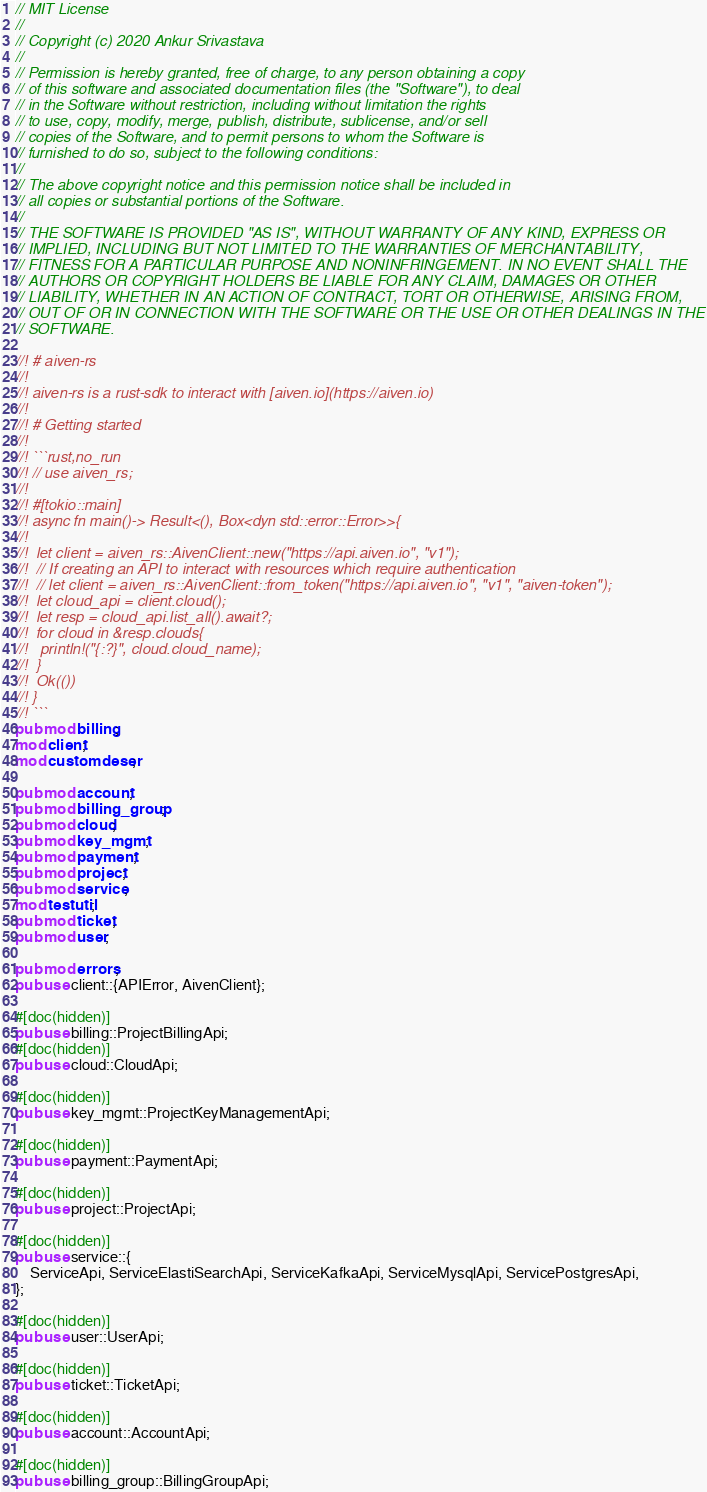<code> <loc_0><loc_0><loc_500><loc_500><_Rust_>// MIT License
//
// Copyright (c) 2020 Ankur Srivastava
//
// Permission is hereby granted, free of charge, to any person obtaining a copy
// of this software and associated documentation files (the "Software"), to deal
// in the Software without restriction, including without limitation the rights
// to use, copy, modify, merge, publish, distribute, sublicense, and/or sell
// copies of the Software, and to permit persons to whom the Software is
// furnished to do so, subject to the following conditions:
//
// The above copyright notice and this permission notice shall be included in
// all copies or substantial portions of the Software.
//
// THE SOFTWARE IS PROVIDED "AS IS", WITHOUT WARRANTY OF ANY KIND, EXPRESS OR
// IMPLIED, INCLUDING BUT NOT LIMITED TO THE WARRANTIES OF MERCHANTABILITY,
// FITNESS FOR A PARTICULAR PURPOSE AND NONINFRINGEMENT. IN NO EVENT SHALL THE
// AUTHORS OR COPYRIGHT HOLDERS BE LIABLE FOR ANY CLAIM, DAMAGES OR OTHER
// LIABILITY, WHETHER IN AN ACTION OF CONTRACT, TORT OR OTHERWISE, ARISING FROM,
// OUT OF OR IN CONNECTION WITH THE SOFTWARE OR THE USE OR OTHER DEALINGS IN THE
// SOFTWARE.

//! # aiven-rs
//!
//! aiven-rs is a rust-sdk to interact with [aiven.io](https://aiven.io)
//!
//! # Getting started
//!
//! ```rust,no_run
//! // use aiven_rs;
//!
//! #[tokio::main]
//! async fn main()-> Result<(), Box<dyn std::error::Error>>{
//!
//!  let client = aiven_rs::AivenClient::new("https://api.aiven.io", "v1");
//!  // If creating an API to interact with resources which require authentication
//!  // let client = aiven_rs::AivenClient::from_token("https://api.aiven.io", "v1", "aiven-token");
//!  let cloud_api = client.cloud();
//!  let resp = cloud_api.list_all().await?;
//!  for cloud in &resp.clouds{
//!   println!("{:?}", cloud.cloud_name);
//!  }
//!  Ok(())
//! }
//! ```
pub mod billing;
mod client;
mod customdeser;

pub mod account;
pub mod billing_group;
pub mod cloud;
pub mod key_mgmt;
pub mod payment;
pub mod project;
pub mod service;
mod testutil;
pub mod ticket;
pub mod user;

pub mod errors;
pub use client::{APIError, AivenClient};

#[doc(hidden)]
pub use billing::ProjectBillingApi;
#[doc(hidden)]
pub use cloud::CloudApi;

#[doc(hidden)]
pub use key_mgmt::ProjectKeyManagementApi;

#[doc(hidden)]
pub use payment::PaymentApi;

#[doc(hidden)]
pub use project::ProjectApi;

#[doc(hidden)]
pub use service::{
	ServiceApi, ServiceElastiSearchApi, ServiceKafkaApi, ServiceMysqlApi, ServicePostgresApi,
};

#[doc(hidden)]
pub use user::UserApi;

#[doc(hidden)]
pub use ticket::TicketApi;

#[doc(hidden)]
pub use account::AccountApi;

#[doc(hidden)]
pub use billing_group::BillingGroupApi;
</code> 